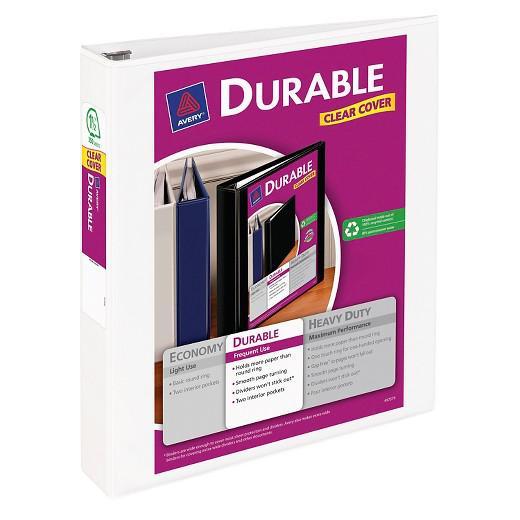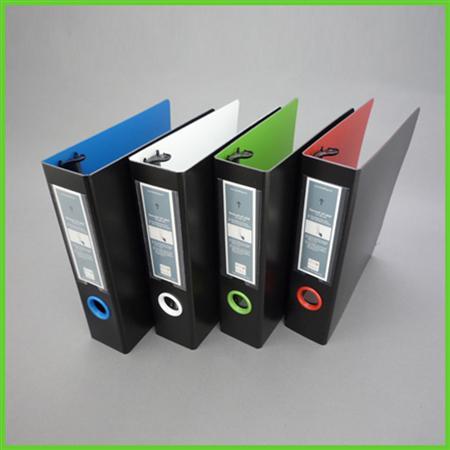The first image is the image on the left, the second image is the image on the right. For the images shown, is this caption "The left image contains a single binder, and the right image contains a row of upright binders with circles on the bound edges." true? Answer yes or no. Yes. The first image is the image on the left, the second image is the image on the right. Examine the images to the left and right. Is the description "The right image contains at least four binders standing vertically." accurate? Answer yes or no. Yes. 